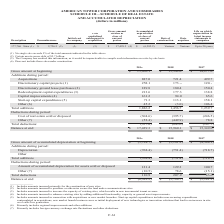According to American Tower Corporation's financial document, What does Discretionary capital projects include? amounts incurred primarily for the construction of new sites.. The document states: "_______________ (1) Includes amounts incurred primarily for the construction of new sites...." Also, What does Redevelopment capital expenditures include? Includes amounts incurred to increase the capacity of existing sites, which results in new incremental tenant revenue.. The document states: "(3) Includes amounts incurred to increase the capacity of existing sites, which results in new incremental tenant revenue...." Also, How much was Acquisitions in 2019? According to the financial document, 887.0 (in millions). The relevant text states: "Acquisitions 887.0 721.4 499.7..." Also, How many additions during 2018 exceeded $200 million? Based on the analysis, there are 1 instances. The counting process: Acquisitions. Also, How many years did total additions exceed $1,500 million? Based on the analysis, there are 1 instances. The counting process: 2019. Also, can you calculate: What was the percentage change of the balance at the end between 2018 and 2019? To answer this question, I need to perform calculations using the financial data. The calculation is: ($17,429.3-$15,960.1)/$15,960.1, which equals 9.21 (percentage). This is based on the information: "177,746 Sites (1) $ 2,736.5 (2) (3) (3) $ 17,429.3 (4) $ (6,382.2) Various Various Up to 20 years Gross amount at beginning $ 15,960.1 $ 15,349.0 $ 14,277.0..." The key data points involved are: 15,960.1, 17,429.3. 